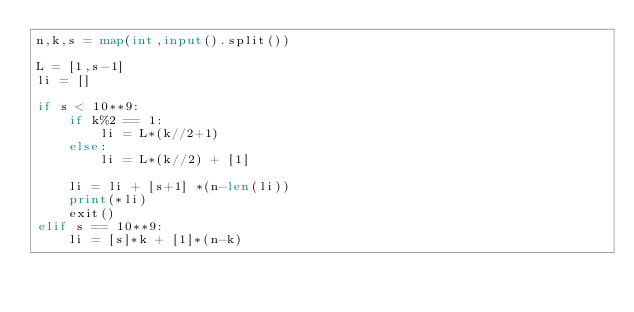<code> <loc_0><loc_0><loc_500><loc_500><_Python_>n,k,s = map(int,input().split())

L = [1,s-1]
li = []

if s < 10**9:
    if k%2 == 1:
        li = L*(k//2+1)
    else:
        li = L*(k//2) + [1]

    li = li + [s+1] *(n-len(li))
    print(*li)
    exit()
elif s == 10**9:
    li = [s]*k + [1]*(n-k)</code> 